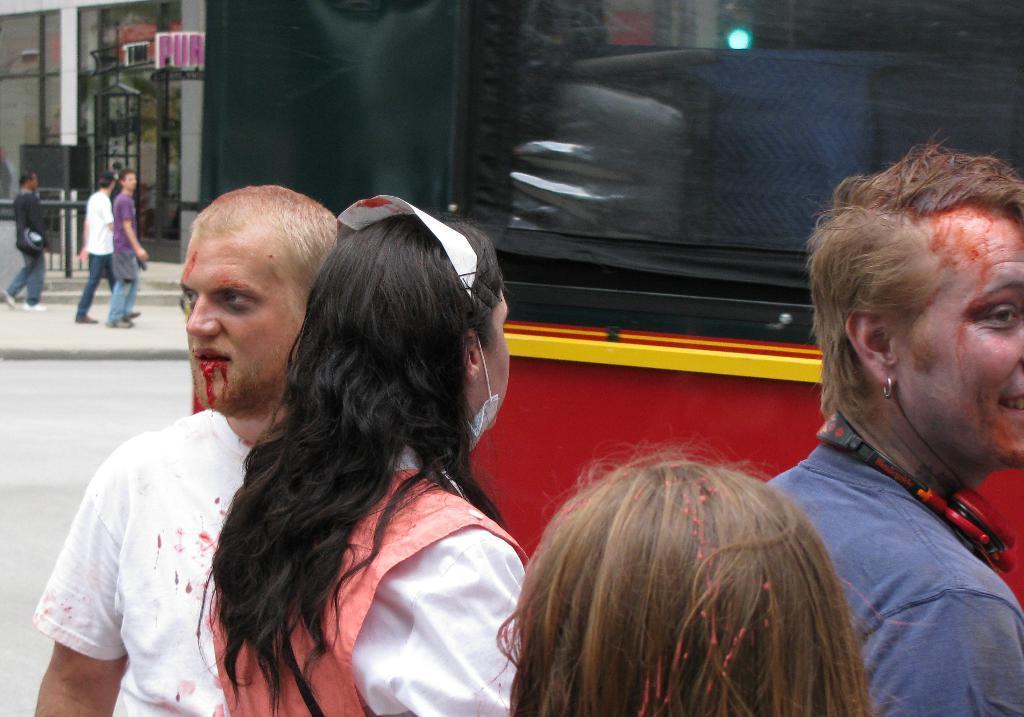Can you describe this image briefly? In this picture I can see group of people, there is a vehicle and a building. 